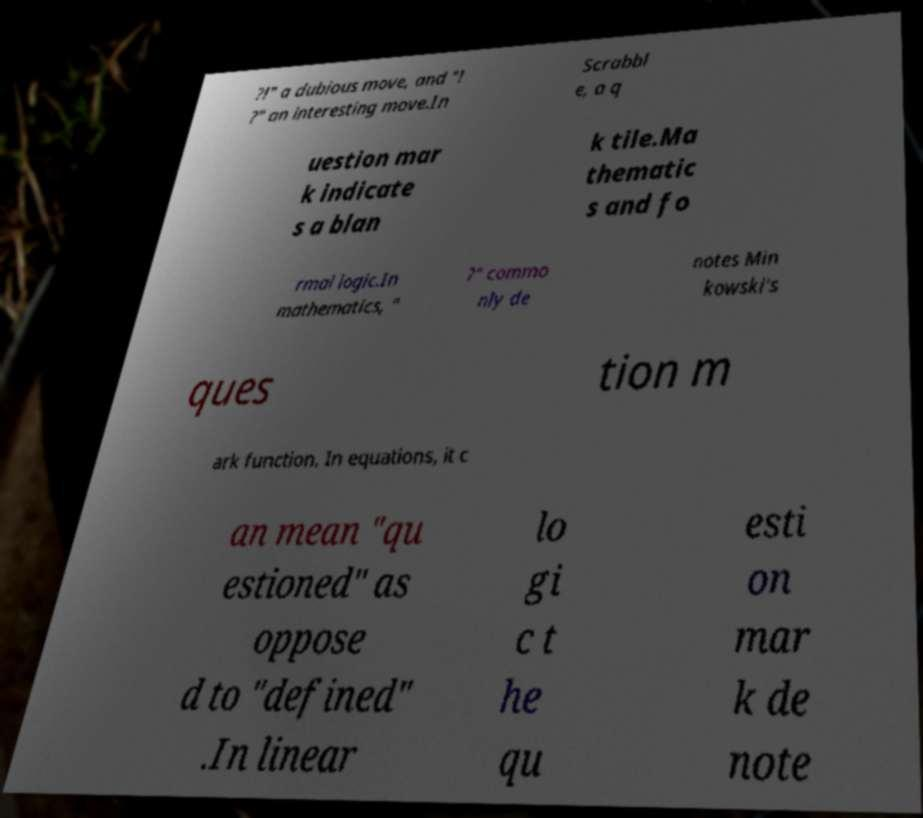I need the written content from this picture converted into text. Can you do that? ?!" a dubious move, and "! ?" an interesting move.In Scrabbl e, a q uestion mar k indicate s a blan k tile.Ma thematic s and fo rmal logic.In mathematics, " ?" commo nly de notes Min kowski's ques tion m ark function. In equations, it c an mean "qu estioned" as oppose d to "defined" .In linear lo gi c t he qu esti on mar k de note 